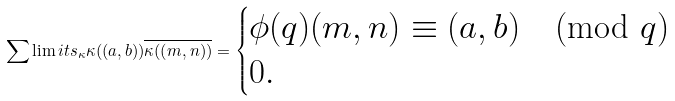Convert formula to latex. <formula><loc_0><loc_0><loc_500><loc_500>\sum \lim i t s _ { \kappa } \kappa ( ( a , b ) ) \overline { \kappa ( ( m , n ) ) } = \begin{cases} \phi ( q ) ( m , n ) \equiv ( a , b ) \pmod { q } \\ 0 . \end{cases}</formula> 